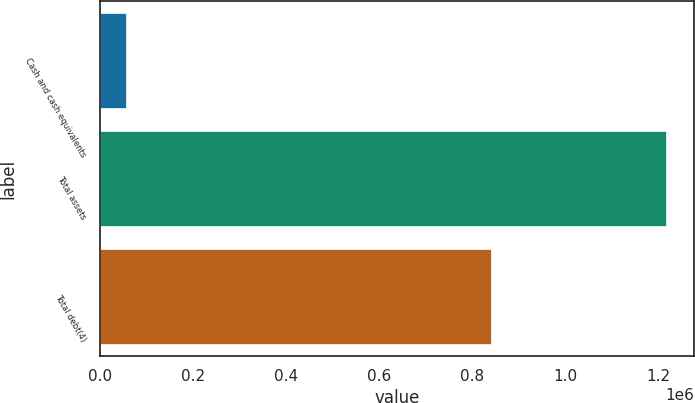Convert chart. <chart><loc_0><loc_0><loc_500><loc_500><bar_chart><fcel>Cash and cash equivalents<fcel>Total assets<fcel>Total debt(4)<nl><fcel>54974<fcel>1.21709e+06<fcel>839543<nl></chart> 